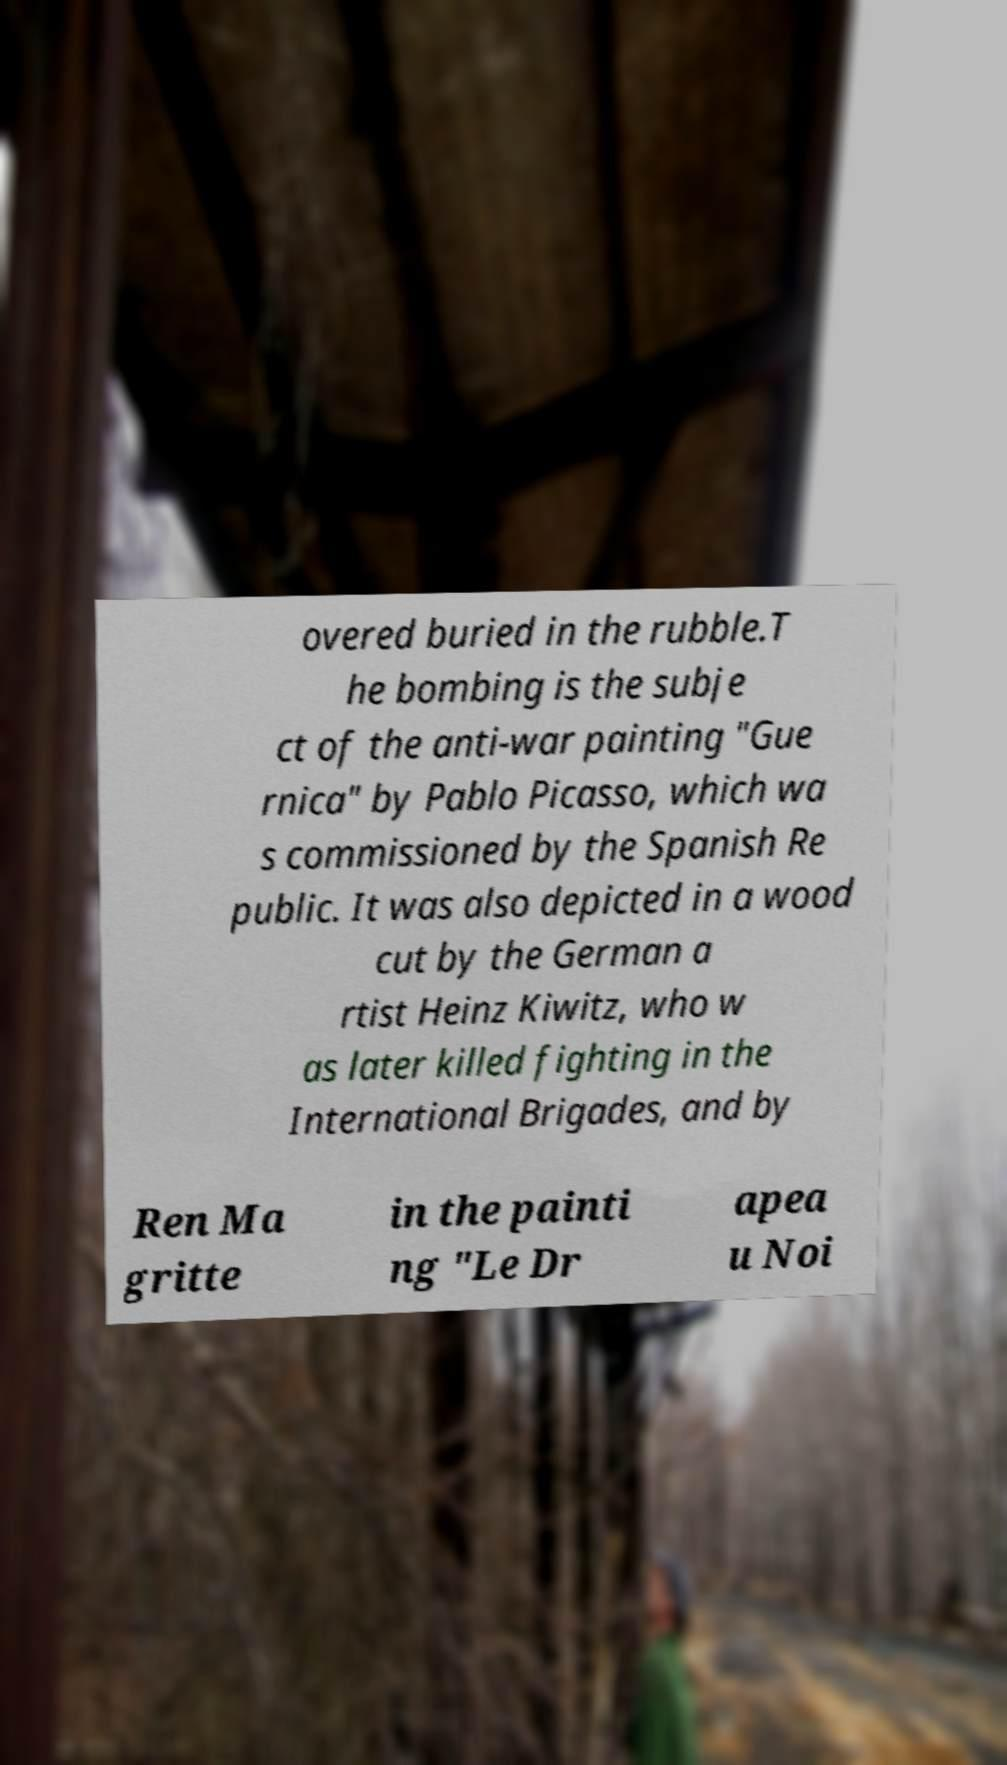Please read and relay the text visible in this image. What does it say? overed buried in the rubble.T he bombing is the subje ct of the anti-war painting "Gue rnica" by Pablo Picasso, which wa s commissioned by the Spanish Re public. It was also depicted in a wood cut by the German a rtist Heinz Kiwitz, who w as later killed fighting in the International Brigades, and by Ren Ma gritte in the painti ng "Le Dr apea u Noi 